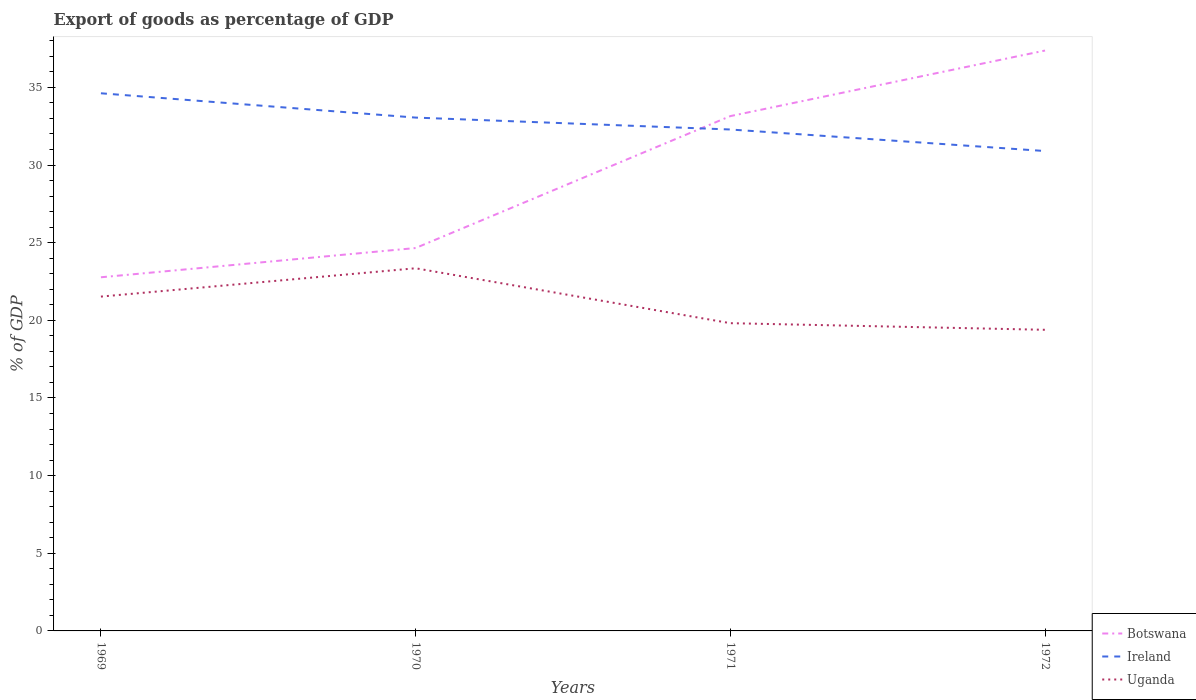Is the number of lines equal to the number of legend labels?
Ensure brevity in your answer.  Yes. Across all years, what is the maximum export of goods as percentage of GDP in Botswana?
Your response must be concise. 22.77. In which year was the export of goods as percentage of GDP in Uganda maximum?
Make the answer very short. 1972. What is the total export of goods as percentage of GDP in Uganda in the graph?
Ensure brevity in your answer.  1.71. What is the difference between the highest and the second highest export of goods as percentage of GDP in Botswana?
Ensure brevity in your answer.  14.6. What is the difference between the highest and the lowest export of goods as percentage of GDP in Ireland?
Provide a succinct answer. 2. Is the export of goods as percentage of GDP in Botswana strictly greater than the export of goods as percentage of GDP in Uganda over the years?
Ensure brevity in your answer.  No. How many lines are there?
Provide a short and direct response. 3. What is the difference between two consecutive major ticks on the Y-axis?
Your answer should be compact. 5. Are the values on the major ticks of Y-axis written in scientific E-notation?
Give a very brief answer. No. Does the graph contain any zero values?
Keep it short and to the point. No. Does the graph contain grids?
Your response must be concise. No. Where does the legend appear in the graph?
Your answer should be very brief. Bottom right. How many legend labels are there?
Keep it short and to the point. 3. How are the legend labels stacked?
Give a very brief answer. Vertical. What is the title of the graph?
Your answer should be compact. Export of goods as percentage of GDP. Does "Netherlands" appear as one of the legend labels in the graph?
Offer a terse response. No. What is the label or title of the Y-axis?
Offer a very short reply. % of GDP. What is the % of GDP in Botswana in 1969?
Give a very brief answer. 22.77. What is the % of GDP of Ireland in 1969?
Ensure brevity in your answer.  34.62. What is the % of GDP of Uganda in 1969?
Offer a terse response. 21.53. What is the % of GDP in Botswana in 1970?
Provide a succinct answer. 24.66. What is the % of GDP in Ireland in 1970?
Your answer should be compact. 33.05. What is the % of GDP in Uganda in 1970?
Offer a terse response. 23.35. What is the % of GDP in Botswana in 1971?
Provide a succinct answer. 33.15. What is the % of GDP in Ireland in 1971?
Make the answer very short. 32.29. What is the % of GDP in Uganda in 1971?
Offer a terse response. 19.82. What is the % of GDP in Botswana in 1972?
Your response must be concise. 37.37. What is the % of GDP of Ireland in 1972?
Your response must be concise. 30.9. What is the % of GDP in Uganda in 1972?
Provide a succinct answer. 19.39. Across all years, what is the maximum % of GDP of Botswana?
Your answer should be very brief. 37.37. Across all years, what is the maximum % of GDP of Ireland?
Offer a terse response. 34.62. Across all years, what is the maximum % of GDP in Uganda?
Provide a succinct answer. 23.35. Across all years, what is the minimum % of GDP in Botswana?
Offer a very short reply. 22.77. Across all years, what is the minimum % of GDP in Ireland?
Offer a very short reply. 30.9. Across all years, what is the minimum % of GDP in Uganda?
Your response must be concise. 19.39. What is the total % of GDP in Botswana in the graph?
Your answer should be very brief. 117.95. What is the total % of GDP of Ireland in the graph?
Ensure brevity in your answer.  130.86. What is the total % of GDP in Uganda in the graph?
Offer a terse response. 84.09. What is the difference between the % of GDP in Botswana in 1969 and that in 1970?
Your answer should be compact. -1.88. What is the difference between the % of GDP of Ireland in 1969 and that in 1970?
Your answer should be compact. 1.57. What is the difference between the % of GDP in Uganda in 1969 and that in 1970?
Make the answer very short. -1.82. What is the difference between the % of GDP in Botswana in 1969 and that in 1971?
Offer a very short reply. -10.38. What is the difference between the % of GDP in Ireland in 1969 and that in 1971?
Provide a succinct answer. 2.33. What is the difference between the % of GDP in Uganda in 1969 and that in 1971?
Your answer should be very brief. 1.71. What is the difference between the % of GDP in Botswana in 1969 and that in 1972?
Give a very brief answer. -14.6. What is the difference between the % of GDP in Ireland in 1969 and that in 1972?
Give a very brief answer. 3.72. What is the difference between the % of GDP in Uganda in 1969 and that in 1972?
Keep it short and to the point. 2.14. What is the difference between the % of GDP of Botswana in 1970 and that in 1971?
Your answer should be very brief. -8.49. What is the difference between the % of GDP in Ireland in 1970 and that in 1971?
Provide a short and direct response. 0.77. What is the difference between the % of GDP of Uganda in 1970 and that in 1971?
Give a very brief answer. 3.54. What is the difference between the % of GDP in Botswana in 1970 and that in 1972?
Provide a succinct answer. -12.72. What is the difference between the % of GDP in Ireland in 1970 and that in 1972?
Your response must be concise. 2.15. What is the difference between the % of GDP in Uganda in 1970 and that in 1972?
Offer a very short reply. 3.96. What is the difference between the % of GDP in Botswana in 1971 and that in 1972?
Keep it short and to the point. -4.22. What is the difference between the % of GDP in Ireland in 1971 and that in 1972?
Your answer should be very brief. 1.39. What is the difference between the % of GDP of Uganda in 1971 and that in 1972?
Offer a very short reply. 0.43. What is the difference between the % of GDP in Botswana in 1969 and the % of GDP in Ireland in 1970?
Ensure brevity in your answer.  -10.28. What is the difference between the % of GDP of Botswana in 1969 and the % of GDP of Uganda in 1970?
Your response must be concise. -0.58. What is the difference between the % of GDP in Ireland in 1969 and the % of GDP in Uganda in 1970?
Make the answer very short. 11.27. What is the difference between the % of GDP of Botswana in 1969 and the % of GDP of Ireland in 1971?
Your answer should be compact. -9.52. What is the difference between the % of GDP of Botswana in 1969 and the % of GDP of Uganda in 1971?
Offer a terse response. 2.96. What is the difference between the % of GDP in Ireland in 1969 and the % of GDP in Uganda in 1971?
Offer a very short reply. 14.8. What is the difference between the % of GDP in Botswana in 1969 and the % of GDP in Ireland in 1972?
Provide a succinct answer. -8.13. What is the difference between the % of GDP in Botswana in 1969 and the % of GDP in Uganda in 1972?
Keep it short and to the point. 3.38. What is the difference between the % of GDP of Ireland in 1969 and the % of GDP of Uganda in 1972?
Your response must be concise. 15.23. What is the difference between the % of GDP in Botswana in 1970 and the % of GDP in Ireland in 1971?
Your response must be concise. -7.63. What is the difference between the % of GDP in Botswana in 1970 and the % of GDP in Uganda in 1971?
Offer a terse response. 4.84. What is the difference between the % of GDP of Ireland in 1970 and the % of GDP of Uganda in 1971?
Give a very brief answer. 13.24. What is the difference between the % of GDP in Botswana in 1970 and the % of GDP in Ireland in 1972?
Make the answer very short. -6.25. What is the difference between the % of GDP in Botswana in 1970 and the % of GDP in Uganda in 1972?
Keep it short and to the point. 5.27. What is the difference between the % of GDP of Ireland in 1970 and the % of GDP of Uganda in 1972?
Keep it short and to the point. 13.66. What is the difference between the % of GDP in Botswana in 1971 and the % of GDP in Ireland in 1972?
Give a very brief answer. 2.25. What is the difference between the % of GDP of Botswana in 1971 and the % of GDP of Uganda in 1972?
Make the answer very short. 13.76. What is the difference between the % of GDP in Ireland in 1971 and the % of GDP in Uganda in 1972?
Provide a short and direct response. 12.9. What is the average % of GDP in Botswana per year?
Ensure brevity in your answer.  29.49. What is the average % of GDP in Ireland per year?
Your answer should be very brief. 32.72. What is the average % of GDP of Uganda per year?
Provide a short and direct response. 21.02. In the year 1969, what is the difference between the % of GDP of Botswana and % of GDP of Ireland?
Offer a very short reply. -11.85. In the year 1969, what is the difference between the % of GDP of Botswana and % of GDP of Uganda?
Keep it short and to the point. 1.24. In the year 1969, what is the difference between the % of GDP in Ireland and % of GDP in Uganda?
Your answer should be compact. 13.09. In the year 1970, what is the difference between the % of GDP in Botswana and % of GDP in Ireland?
Your answer should be compact. -8.4. In the year 1970, what is the difference between the % of GDP of Botswana and % of GDP of Uganda?
Your answer should be very brief. 1.3. In the year 1970, what is the difference between the % of GDP of Ireland and % of GDP of Uganda?
Offer a very short reply. 9.7. In the year 1971, what is the difference between the % of GDP of Botswana and % of GDP of Ireland?
Give a very brief answer. 0.86. In the year 1971, what is the difference between the % of GDP in Botswana and % of GDP in Uganda?
Offer a very short reply. 13.33. In the year 1971, what is the difference between the % of GDP in Ireland and % of GDP in Uganda?
Offer a terse response. 12.47. In the year 1972, what is the difference between the % of GDP of Botswana and % of GDP of Ireland?
Offer a very short reply. 6.47. In the year 1972, what is the difference between the % of GDP of Botswana and % of GDP of Uganda?
Provide a short and direct response. 17.98. In the year 1972, what is the difference between the % of GDP in Ireland and % of GDP in Uganda?
Your response must be concise. 11.51. What is the ratio of the % of GDP in Botswana in 1969 to that in 1970?
Provide a short and direct response. 0.92. What is the ratio of the % of GDP of Ireland in 1969 to that in 1970?
Give a very brief answer. 1.05. What is the ratio of the % of GDP of Uganda in 1969 to that in 1970?
Your response must be concise. 0.92. What is the ratio of the % of GDP of Botswana in 1969 to that in 1971?
Make the answer very short. 0.69. What is the ratio of the % of GDP of Ireland in 1969 to that in 1971?
Ensure brevity in your answer.  1.07. What is the ratio of the % of GDP of Uganda in 1969 to that in 1971?
Offer a very short reply. 1.09. What is the ratio of the % of GDP in Botswana in 1969 to that in 1972?
Give a very brief answer. 0.61. What is the ratio of the % of GDP of Ireland in 1969 to that in 1972?
Your answer should be compact. 1.12. What is the ratio of the % of GDP in Uganda in 1969 to that in 1972?
Give a very brief answer. 1.11. What is the ratio of the % of GDP of Botswana in 1970 to that in 1971?
Offer a very short reply. 0.74. What is the ratio of the % of GDP of Ireland in 1970 to that in 1971?
Your answer should be very brief. 1.02. What is the ratio of the % of GDP in Uganda in 1970 to that in 1971?
Give a very brief answer. 1.18. What is the ratio of the % of GDP of Botswana in 1970 to that in 1972?
Make the answer very short. 0.66. What is the ratio of the % of GDP in Ireland in 1970 to that in 1972?
Keep it short and to the point. 1.07. What is the ratio of the % of GDP of Uganda in 1970 to that in 1972?
Give a very brief answer. 1.2. What is the ratio of the % of GDP in Botswana in 1971 to that in 1972?
Your response must be concise. 0.89. What is the ratio of the % of GDP in Ireland in 1971 to that in 1972?
Make the answer very short. 1.04. What is the ratio of the % of GDP of Uganda in 1971 to that in 1972?
Your answer should be very brief. 1.02. What is the difference between the highest and the second highest % of GDP of Botswana?
Provide a succinct answer. 4.22. What is the difference between the highest and the second highest % of GDP of Ireland?
Your response must be concise. 1.57. What is the difference between the highest and the second highest % of GDP in Uganda?
Give a very brief answer. 1.82. What is the difference between the highest and the lowest % of GDP in Botswana?
Offer a terse response. 14.6. What is the difference between the highest and the lowest % of GDP of Ireland?
Your response must be concise. 3.72. What is the difference between the highest and the lowest % of GDP of Uganda?
Make the answer very short. 3.96. 